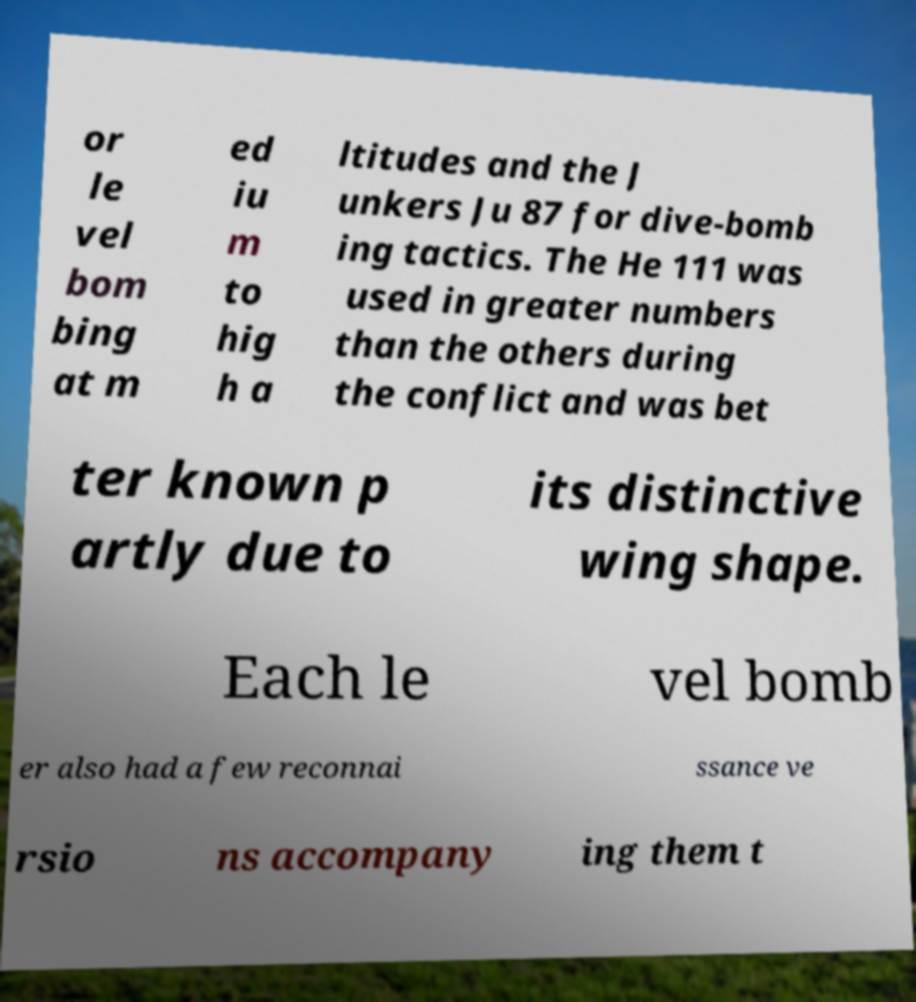For documentation purposes, I need the text within this image transcribed. Could you provide that? or le vel bom bing at m ed iu m to hig h a ltitudes and the J unkers Ju 87 for dive-bomb ing tactics. The He 111 was used in greater numbers than the others during the conflict and was bet ter known p artly due to its distinctive wing shape. Each le vel bomb er also had a few reconnai ssance ve rsio ns accompany ing them t 